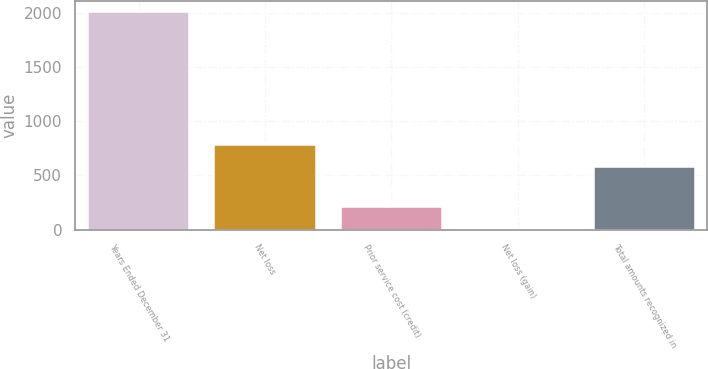Convert chart. <chart><loc_0><loc_0><loc_500><loc_500><bar_chart><fcel>Years Ended December 31<fcel>Net loss<fcel>Prior service cost (credit)<fcel>Net loss (gain)<fcel>Total amounts recognized in<nl><fcel>2012<fcel>782.5<fcel>207.5<fcel>7<fcel>582<nl></chart> 